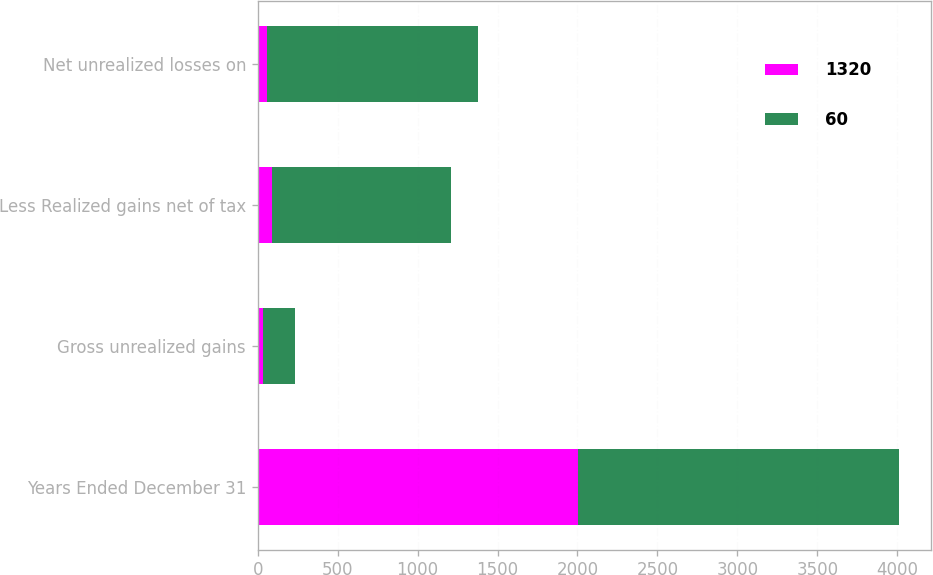<chart> <loc_0><loc_0><loc_500><loc_500><stacked_bar_chart><ecel><fcel>Years Ended December 31<fcel>Gross unrealized gains<fcel>Less Realized gains net of tax<fcel>Net unrealized losses on<nl><fcel>1320<fcel>2006<fcel>31<fcel>91<fcel>60<nl><fcel>60<fcel>2005<fcel>204<fcel>1116<fcel>1320<nl></chart> 